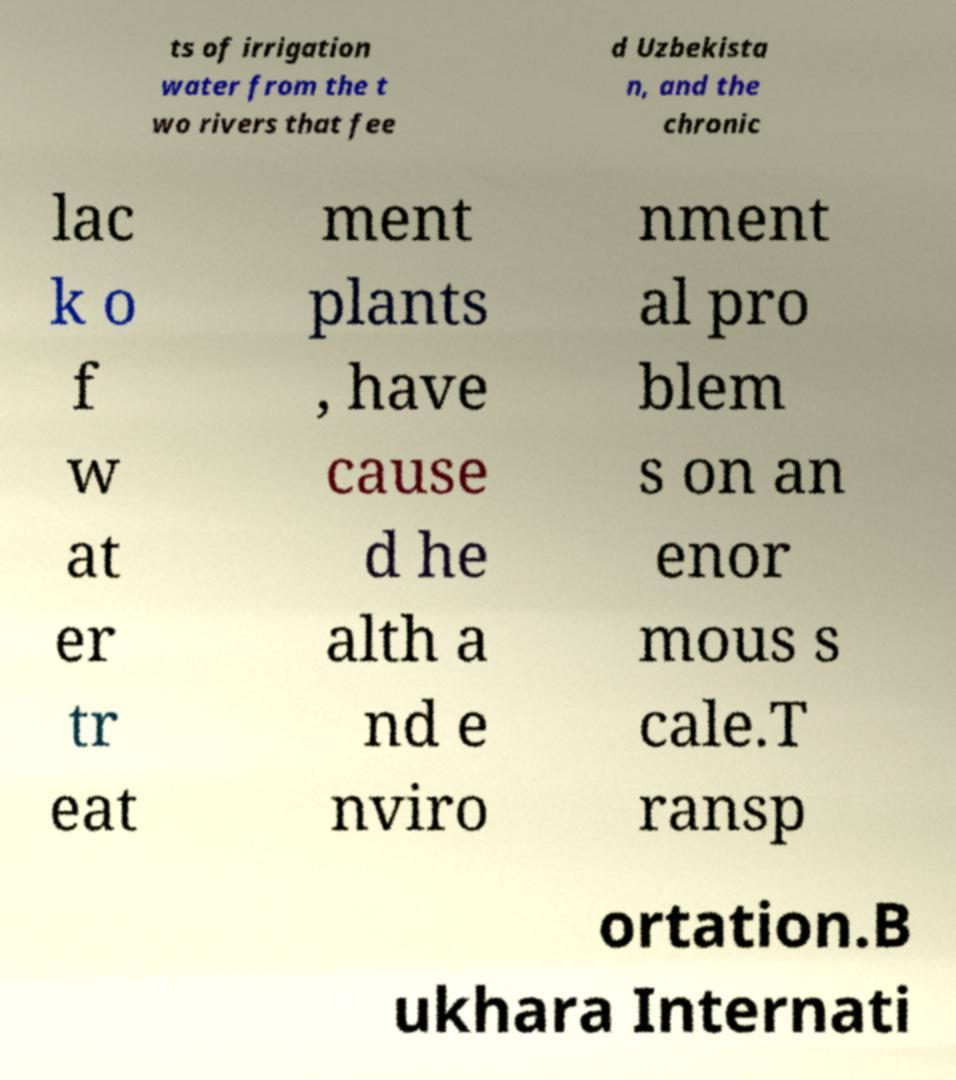Can you accurately transcribe the text from the provided image for me? ts of irrigation water from the t wo rivers that fee d Uzbekista n, and the chronic lac k o f w at er tr eat ment plants , have cause d he alth a nd e nviro nment al pro blem s on an enor mous s cale.T ransp ortation.B ukhara Internati 